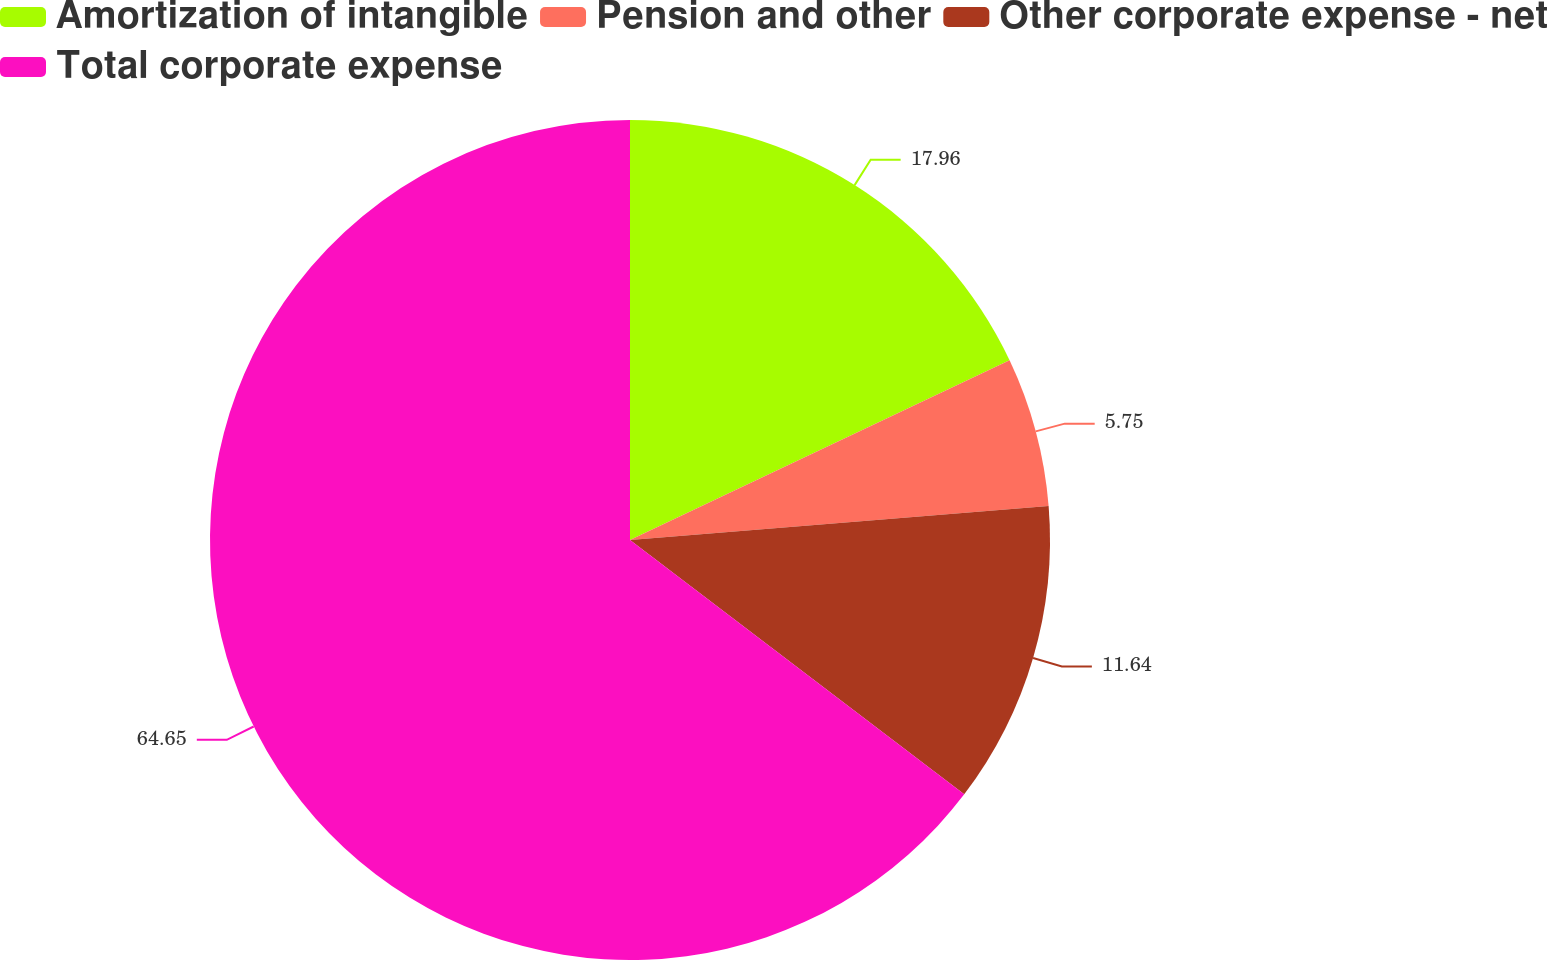Convert chart to OTSL. <chart><loc_0><loc_0><loc_500><loc_500><pie_chart><fcel>Amortization of intangible<fcel>Pension and other<fcel>Other corporate expense - net<fcel>Total corporate expense<nl><fcel>17.96%<fcel>5.75%<fcel>11.64%<fcel>64.64%<nl></chart> 